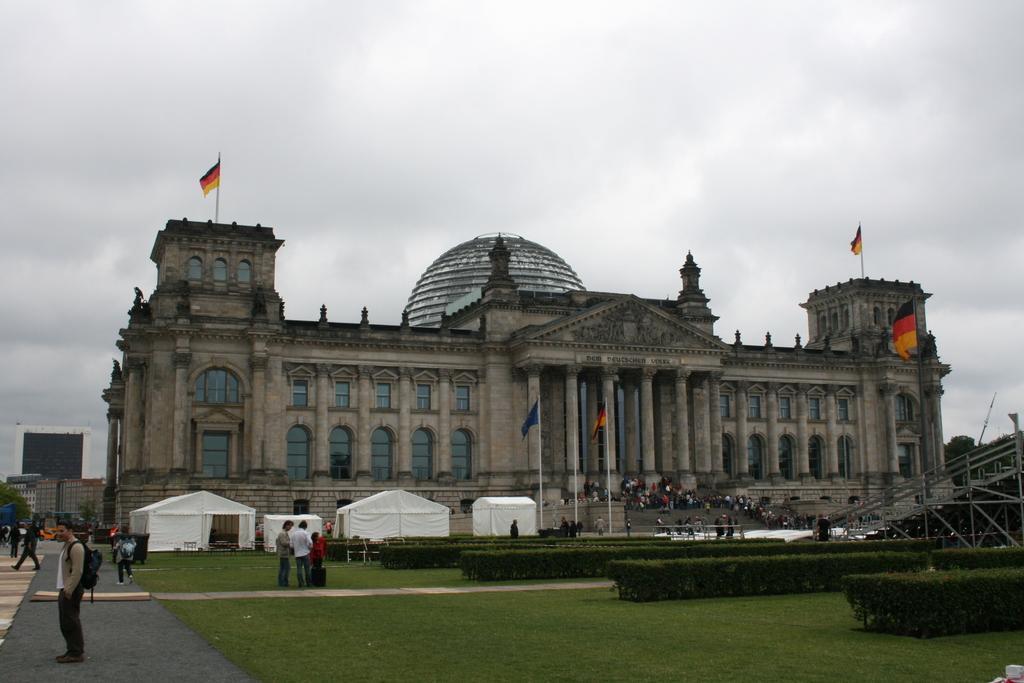Describe this image in one or two sentences. At the bottom of the picture, we see the grass and the pavement. On the left side, we see a man who is wearing a backpack is standing. Beside him, we see the people are standing. In the middle, we see three people are standing. On the right side, we see the shrubs, iron rods and trees. Beside that, we see the people are standing on the staircase. Beside that, we see the flags in blue, orange, red and black color. Beside that, we see the white color tents. In the background, we see a building and the flags. On the left side, we see a tree and buildings. At the top, we see the sky. 